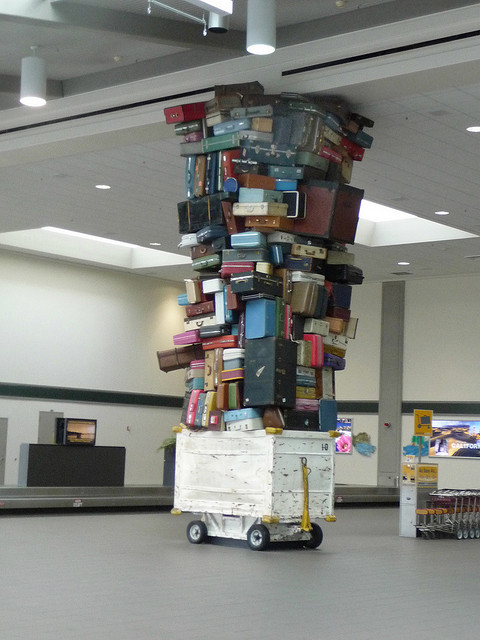How many bikes are? 0 